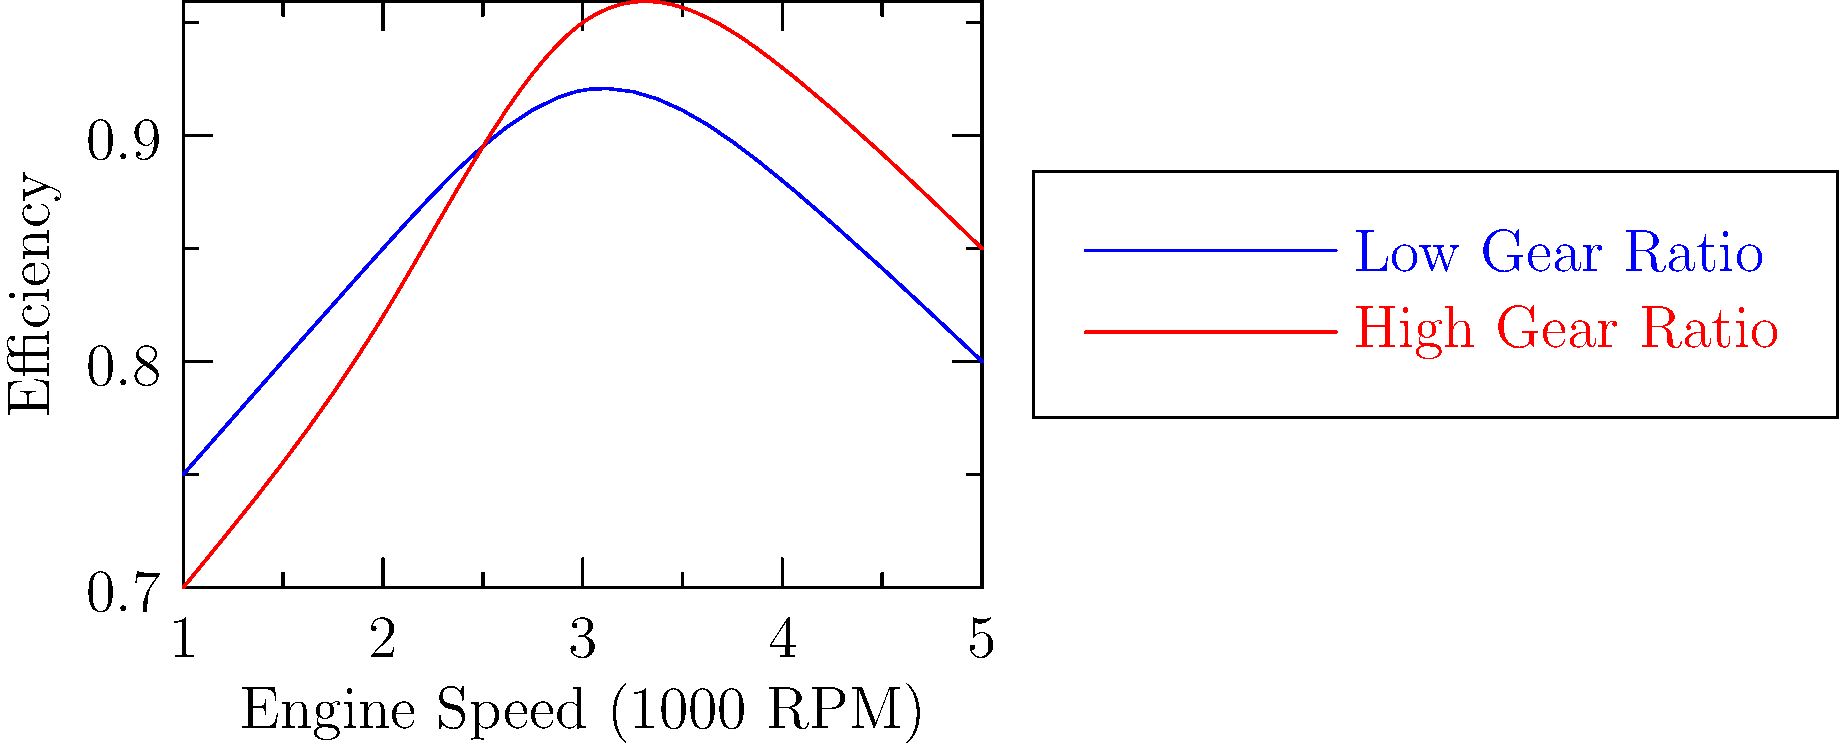As a vintage car restoration expert, you're analyzing the efficiency of different gear ratios in a transmission. The graph shows the efficiency curves for low and high gear ratios across various engine speeds. At which engine speed (in 1000 RPM) does the high gear ratio (red line) become more efficient than the low gear ratio (blue line)? To determine at which engine speed the high gear ratio becomes more efficient than the low gear ratio, we need to follow these steps:

1. Examine the graph, focusing on where the red line (high gear ratio) intersects the blue line (low gear ratio).

2. The point of intersection represents the engine speed at which both gear ratios have equal efficiency.

3. Before this intersection point, the blue line (low gear ratio) is above the red line, indicating higher efficiency for the low gear ratio at lower engine speeds.

4. After the intersection point, the red line (high gear ratio) is above the blue line, indicating higher efficiency for the high gear ratio at higher engine speeds.

5. Locate the x-coordinate of the intersection point on the "Engine Speed (1000 RPM)" axis.

6. The intersection occurs between 2 and 3 on the x-axis, which corresponds to 2000-3000 RPM.

7. More precisely, the intersection appears to be closer to 2.5 on the x-axis, which equates to 2500 RPM.

Therefore, the high gear ratio becomes more efficient than the low gear ratio at approximately 2500 RPM.
Answer: 2500 RPM 